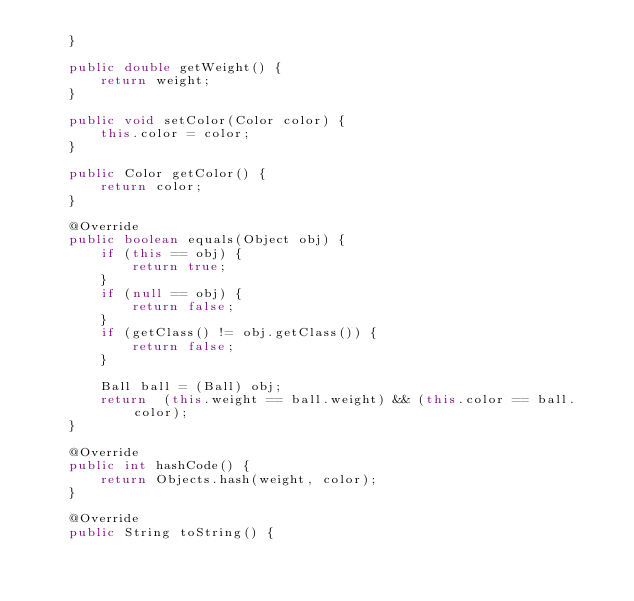Convert code to text. <code><loc_0><loc_0><loc_500><loc_500><_Java_>    }

    public double getWeight() {
        return weight;
    }

    public void setColor(Color color) {
        this.color = color;
    }

    public Color getColor() {
        return color;
    }

    @Override
    public boolean equals(Object obj) {
        if (this == obj) {
            return true;
        }
        if (null == obj) {
            return false;
        }
        if (getClass() != obj.getClass()) {
            return false;
        }

        Ball ball = (Ball) obj;
        return  (this.weight == ball.weight) && (this.color == ball.color);
    }

    @Override
    public int hashCode() {
        return Objects.hash(weight, color);
    }

    @Override
    public String toString() {</code> 